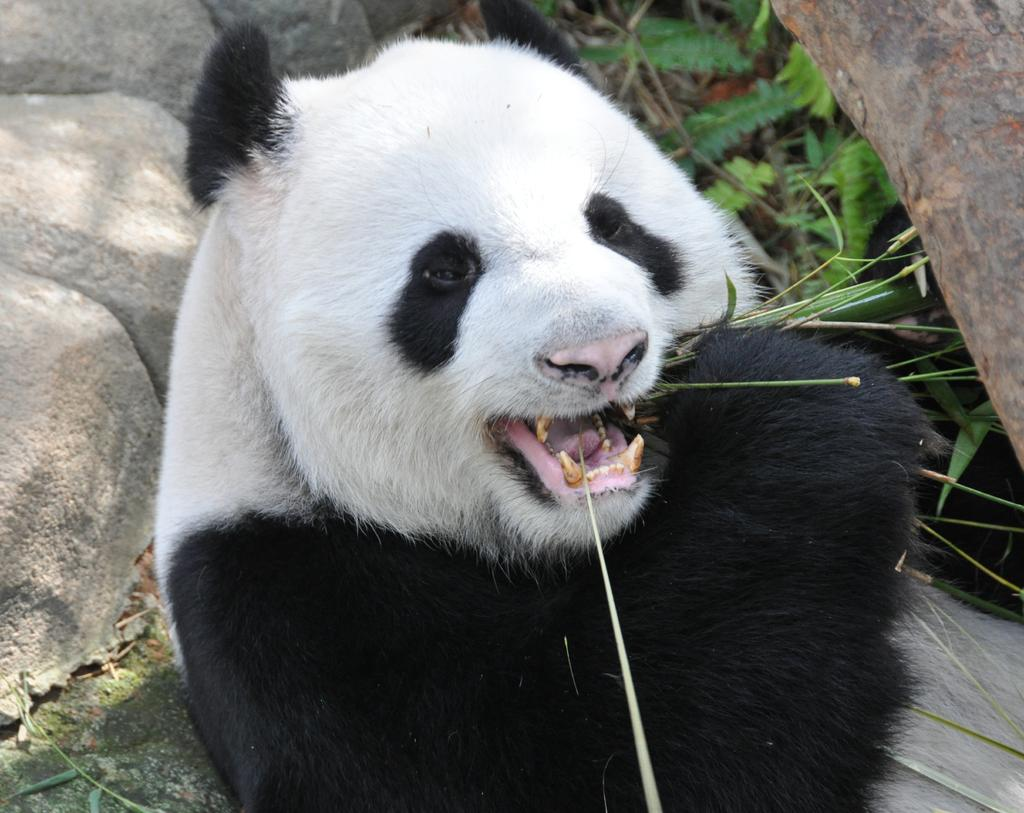What animal is present in the image? There is a panda in the image. What is the panda doing in the image? The panda is eating plants in the image. What can be seen in the background of the image? There are rocks and plants visible in the background of the image. What type of pen is the panda using to write in the image? There is no pen present in the image, and pandas do not use pens to write. 